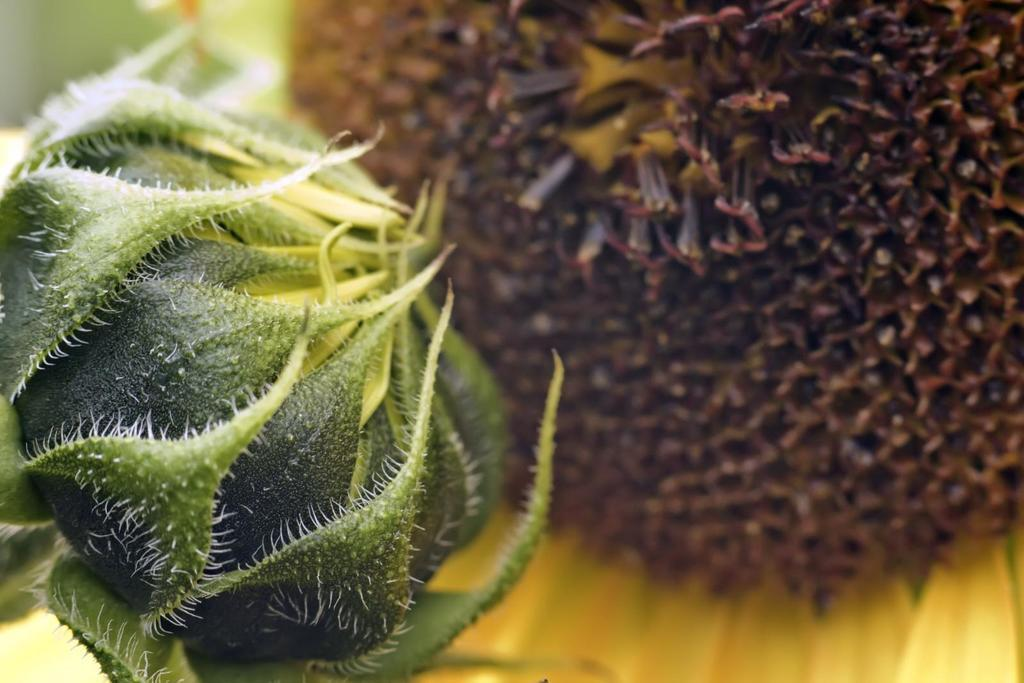What type of living organisms can be seen in the image? There are flowers in the image. What colors are the flowers in the image? The flowers are in green and yellow colors. How does the visitor interact with the flowers in the image? There is no visitor present in the image, so it is not possible to determine how a visitor might interact with the flowers. 